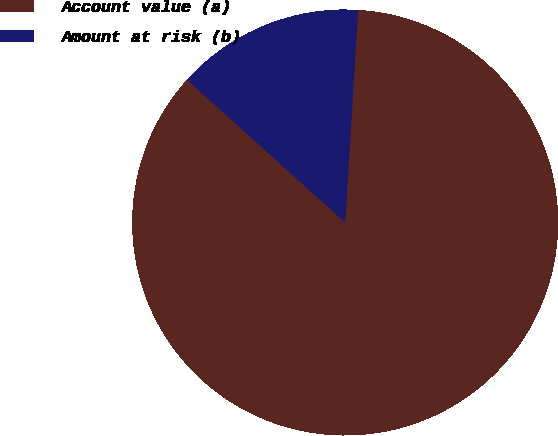<chart> <loc_0><loc_0><loc_500><loc_500><pie_chart><fcel>Account value (a)<fcel>Amount at risk (b)<nl><fcel>85.71%<fcel>14.29%<nl></chart> 